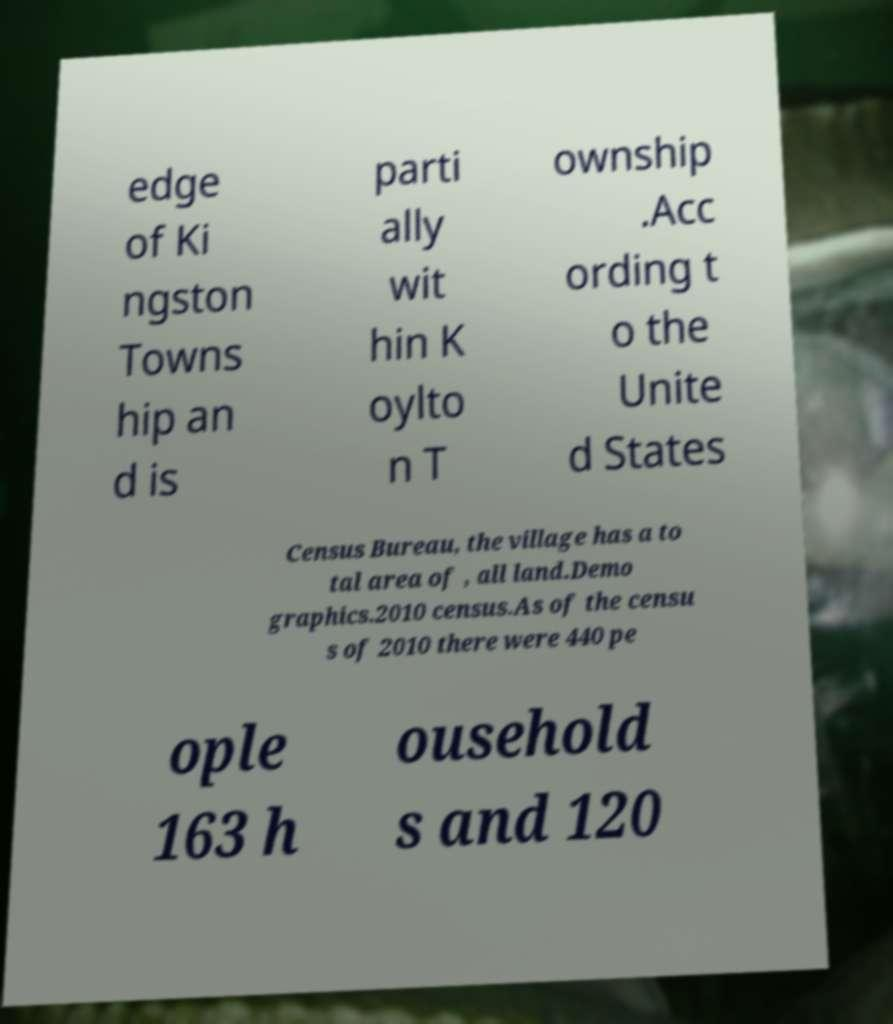Can you accurately transcribe the text from the provided image for me? edge of Ki ngston Towns hip an d is parti ally wit hin K oylto n T ownship .Acc ording t o the Unite d States Census Bureau, the village has a to tal area of , all land.Demo graphics.2010 census.As of the censu s of 2010 there were 440 pe ople 163 h ousehold s and 120 